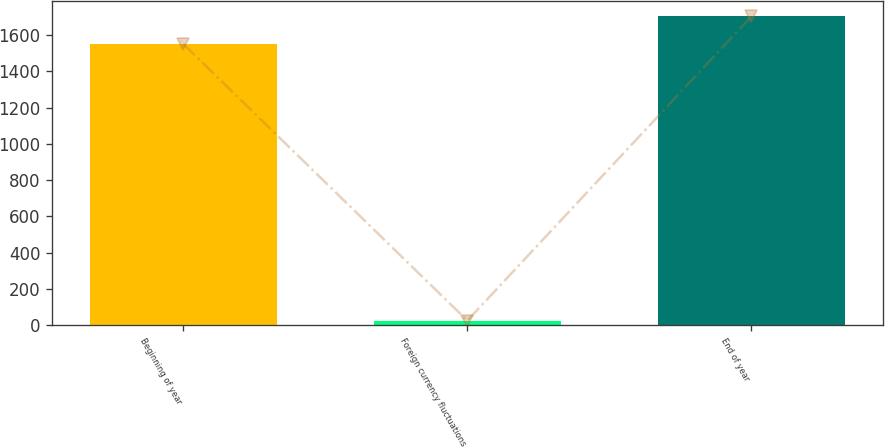Convert chart. <chart><loc_0><loc_0><loc_500><loc_500><bar_chart><fcel>Beginning of year<fcel>Foreign currency fluctuations<fcel>End of year<nl><fcel>1550.7<fcel>25.9<fcel>1703.21<nl></chart> 